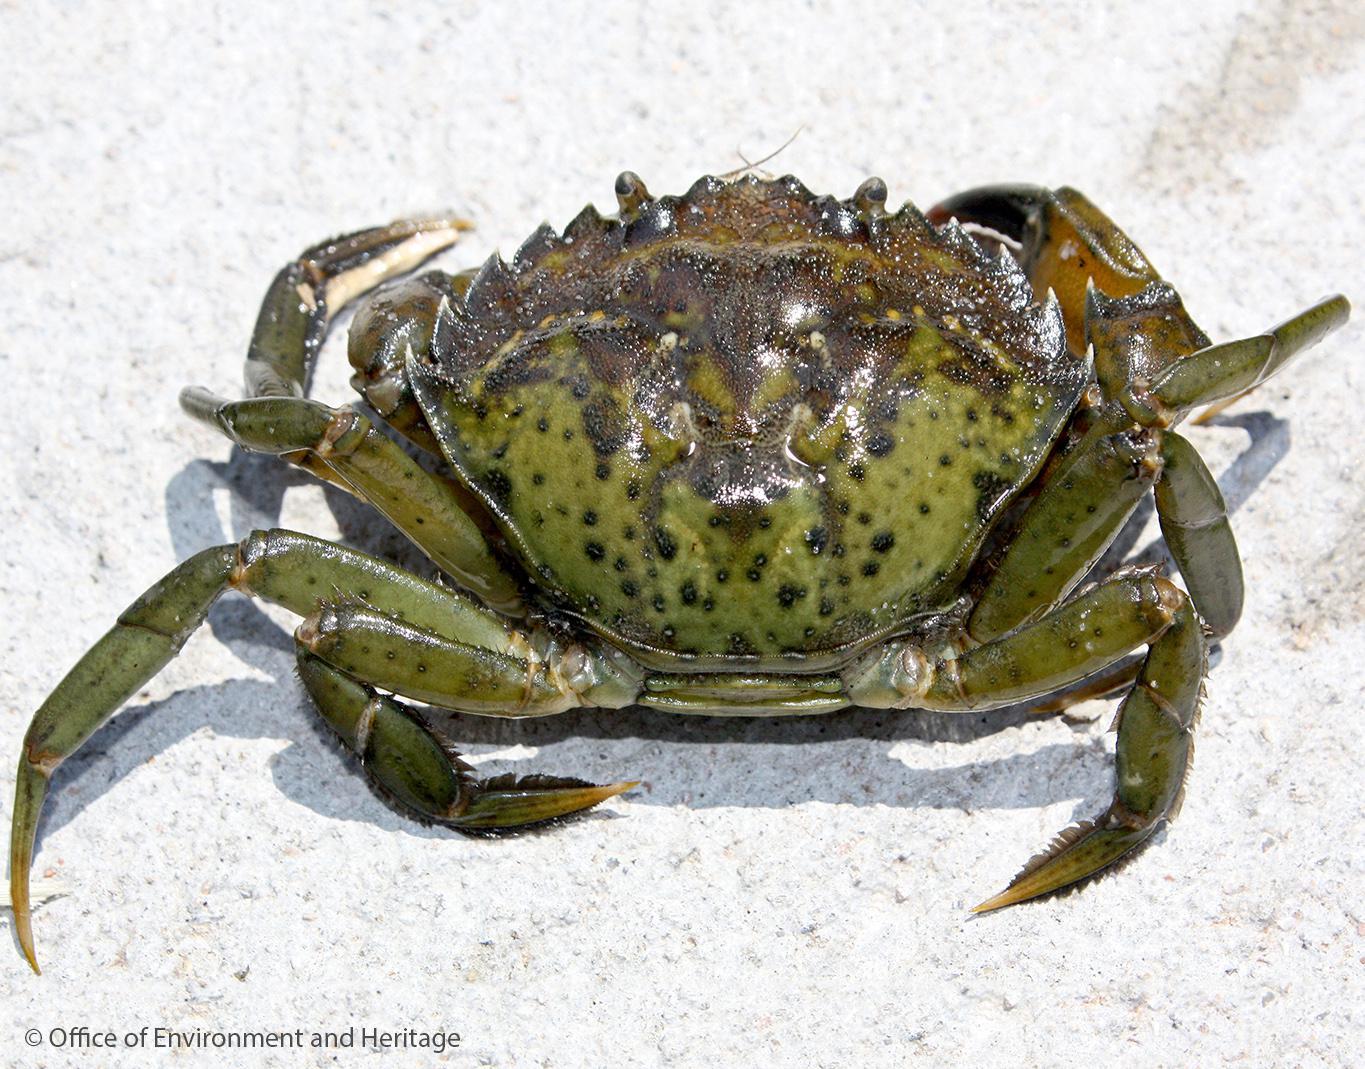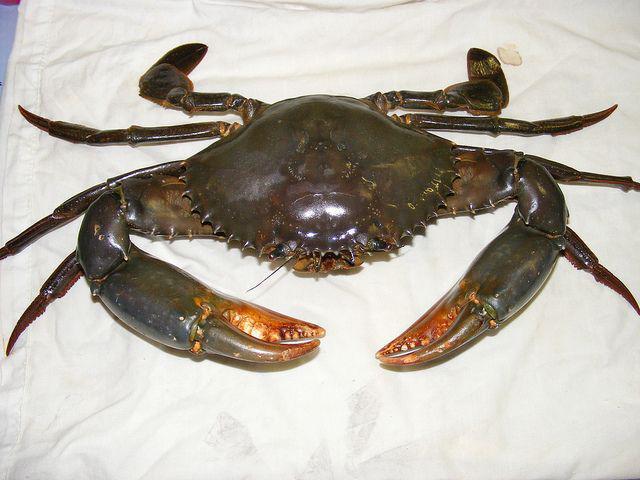The first image is the image on the left, the second image is the image on the right. Examine the images to the left and right. Is the description "The left and right image contains the same number of crabs with at least one with blue claws." accurate? Answer yes or no. No. 